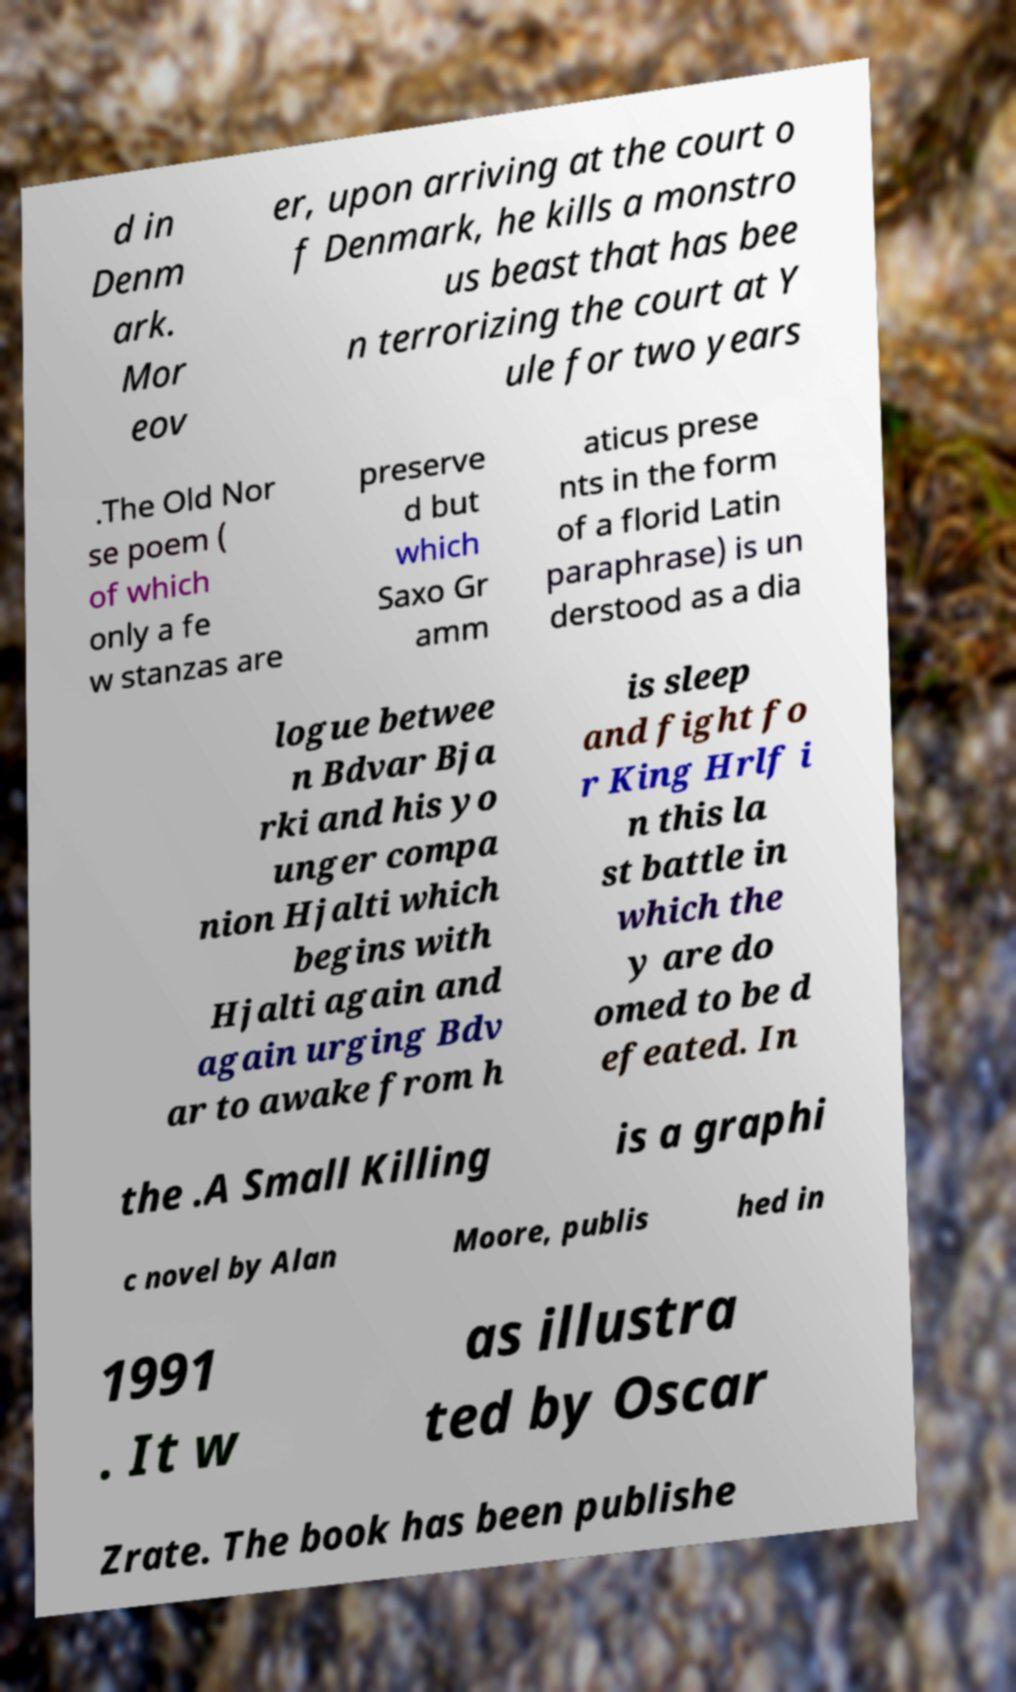Please identify and transcribe the text found in this image. d in Denm ark. Mor eov er, upon arriving at the court o f Denmark, he kills a monstro us beast that has bee n terrorizing the court at Y ule for two years .The Old Nor se poem ( of which only a fe w stanzas are preserve d but which Saxo Gr amm aticus prese nts in the form of a florid Latin paraphrase) is un derstood as a dia logue betwee n Bdvar Bja rki and his yo unger compa nion Hjalti which begins with Hjalti again and again urging Bdv ar to awake from h is sleep and fight fo r King Hrlf i n this la st battle in which the y are do omed to be d efeated. In the .A Small Killing is a graphi c novel by Alan Moore, publis hed in 1991 . It w as illustra ted by Oscar Zrate. The book has been publishe 